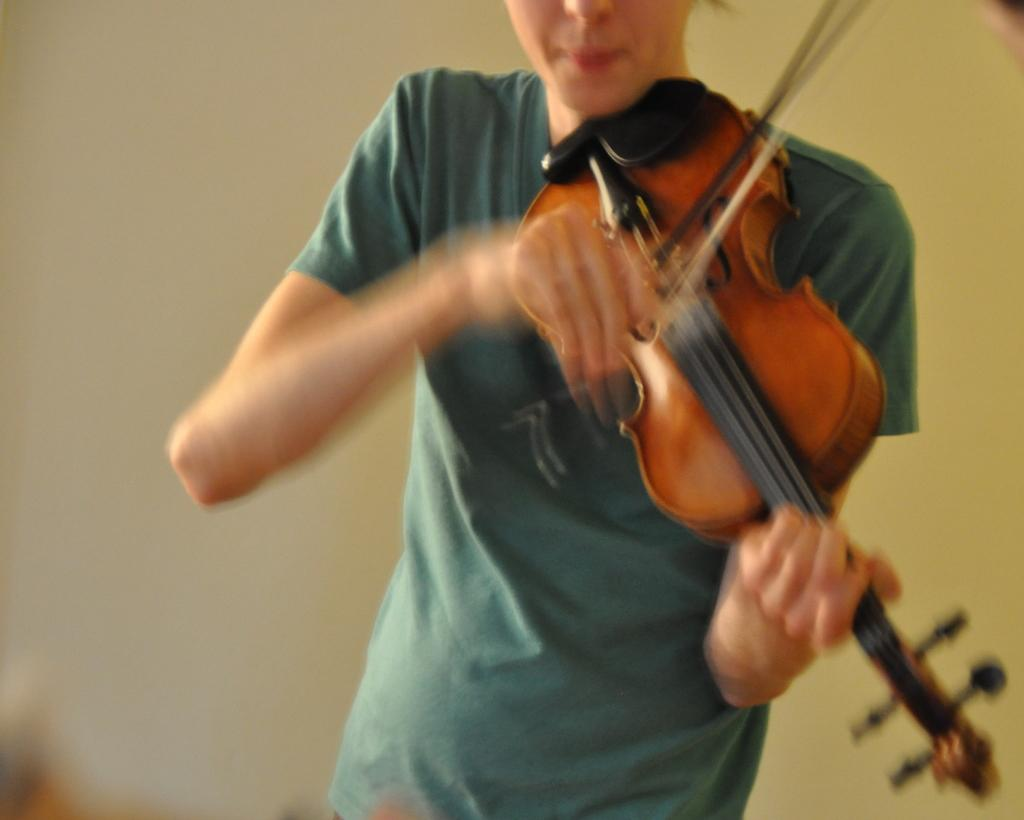What is the main subject of the image? There is a person in the image. What is the person doing in the image? The person is holding a musical instrument. What type of soup is the person eating in the image? There is no soup present in the image; the person is holding a musical instrument. What color are the person's trousers in the image? The provided facts do not mention the person's trousers, so we cannot determine their color from the image. 